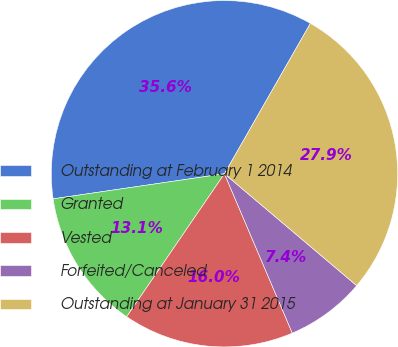<chart> <loc_0><loc_0><loc_500><loc_500><pie_chart><fcel>Outstanding at February 1 2014<fcel>Granted<fcel>Vested<fcel>Forfeited/Canceled<fcel>Outstanding at January 31 2015<nl><fcel>35.58%<fcel>13.14%<fcel>15.95%<fcel>7.42%<fcel>27.91%<nl></chart> 